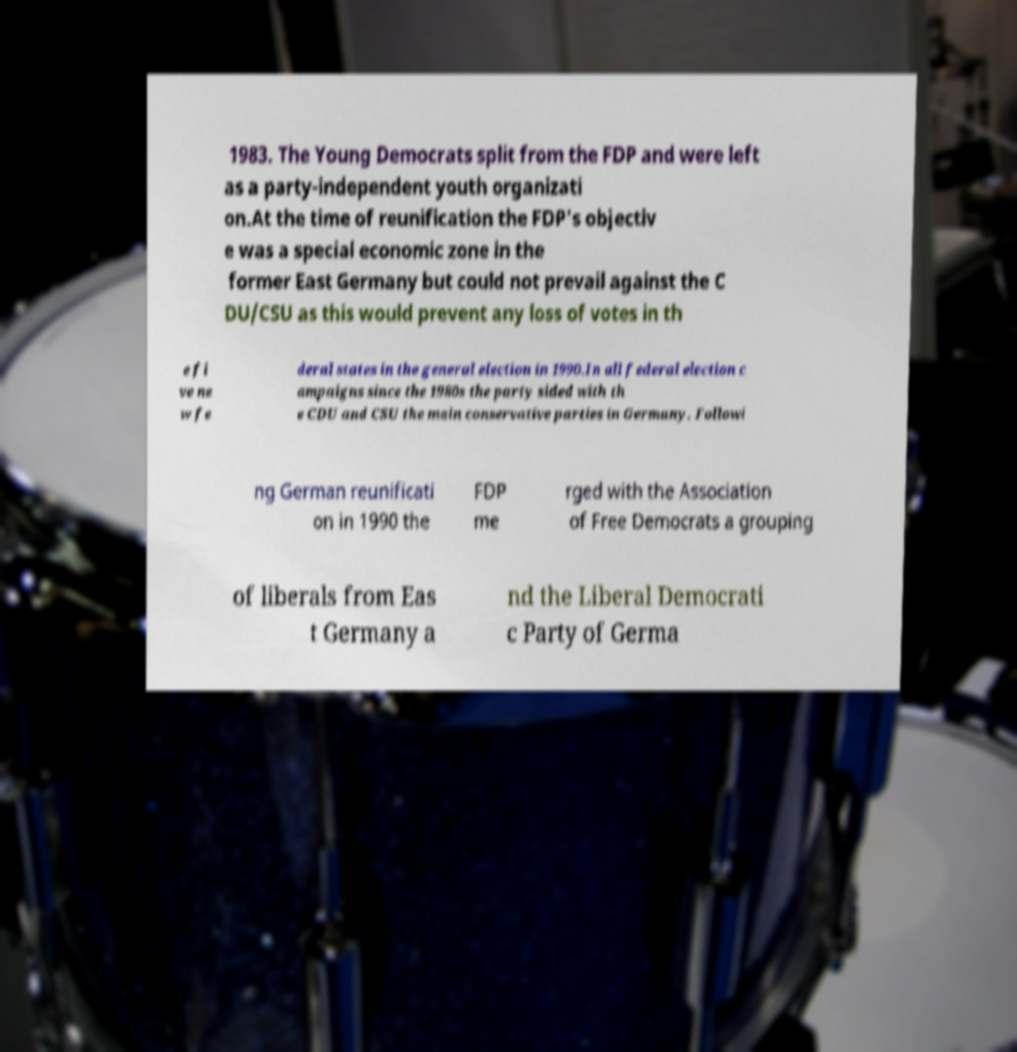Please identify and transcribe the text found in this image. 1983. The Young Democrats split from the FDP and were left as a party-independent youth organizati on.At the time of reunification the FDP's objectiv e was a special economic zone in the former East Germany but could not prevail against the C DU/CSU as this would prevent any loss of votes in th e fi ve ne w fe deral states in the general election in 1990.In all federal election c ampaigns since the 1980s the party sided with th e CDU and CSU the main conservative parties in Germany. Followi ng German reunificati on in 1990 the FDP me rged with the Association of Free Democrats a grouping of liberals from Eas t Germany a nd the Liberal Democrati c Party of Germa 